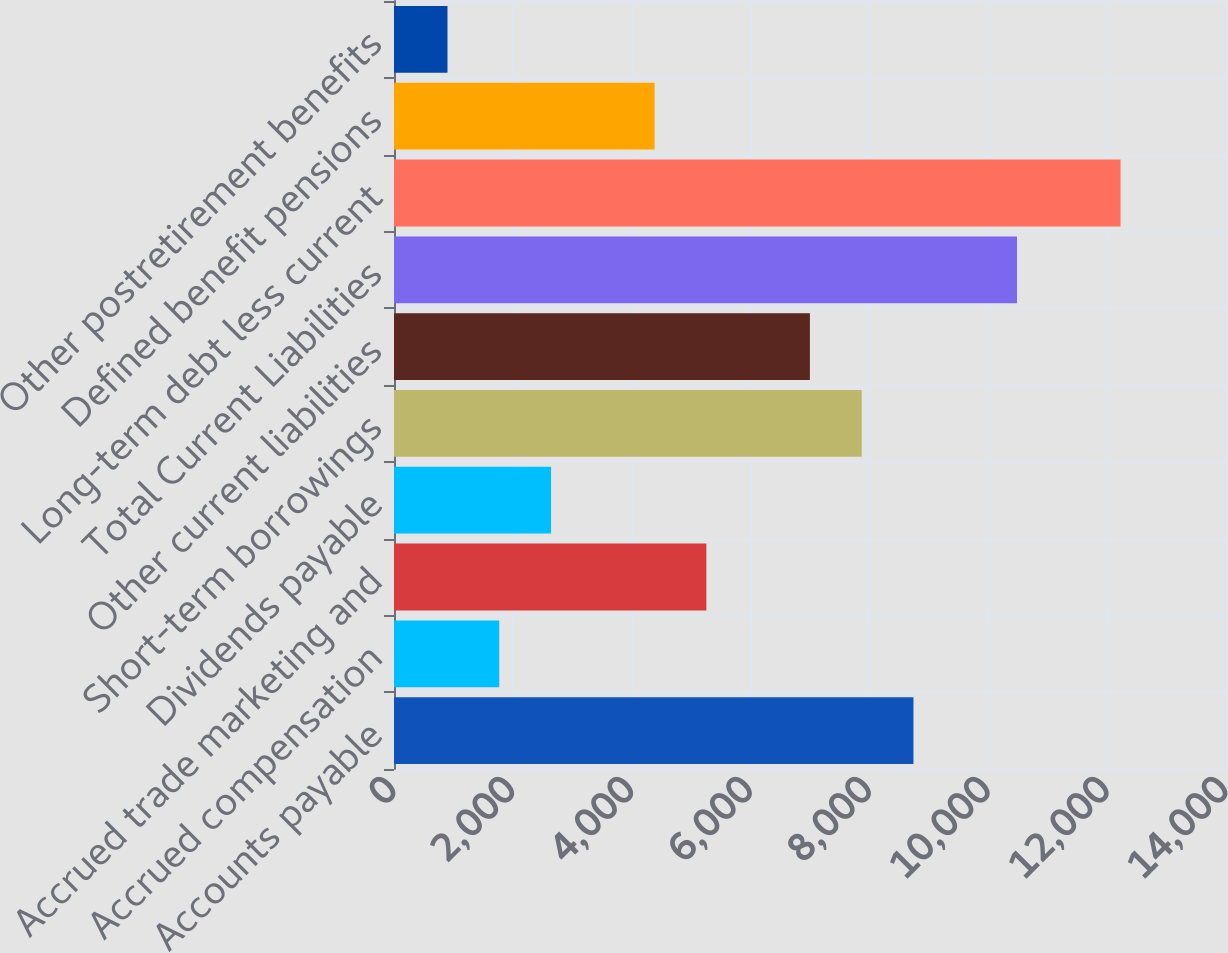Convert chart. <chart><loc_0><loc_0><loc_500><loc_500><bar_chart><fcel>Accounts payable<fcel>Accrued compensation<fcel>Accrued trade marketing and<fcel>Dividends payable<fcel>Short-term borrowings<fcel>Other current liabilities<fcel>Total Current Liabilities<fcel>Long-term debt less current<fcel>Defined benefit pensions<fcel>Other postretirement benefits<nl><fcel>8740.8<fcel>1771.28<fcel>5256.04<fcel>2642.47<fcel>7869.61<fcel>6998.42<fcel>10483.2<fcel>12225.6<fcel>4384.85<fcel>900.09<nl></chart> 